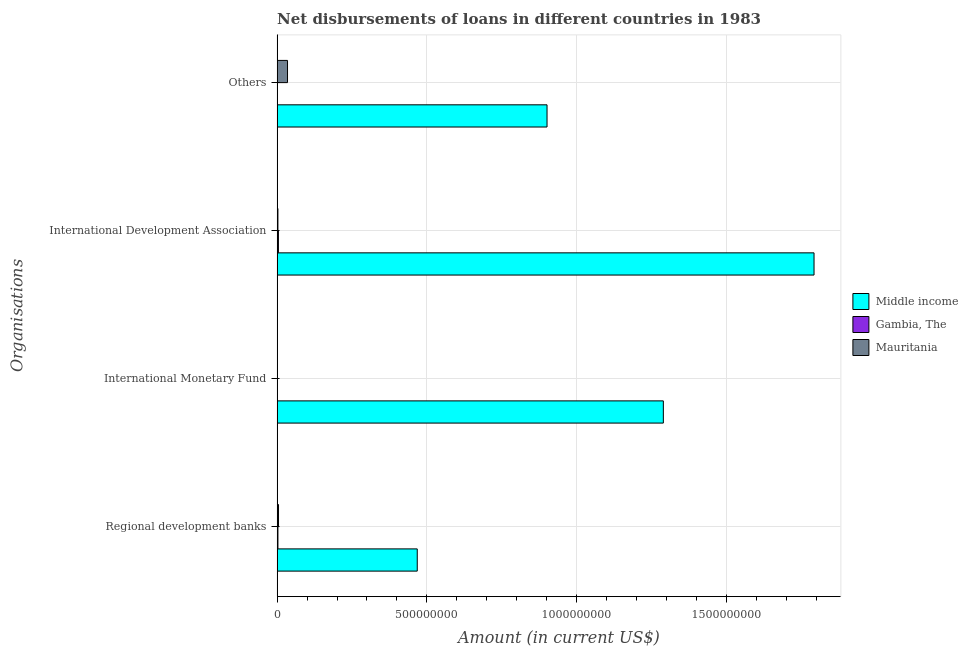Are the number of bars per tick equal to the number of legend labels?
Your answer should be very brief. No. Are the number of bars on each tick of the Y-axis equal?
Offer a very short reply. No. How many bars are there on the 2nd tick from the top?
Keep it short and to the point. 3. What is the label of the 2nd group of bars from the top?
Provide a succinct answer. International Development Association. What is the amount of loan disimbursed by international monetary fund in Mauritania?
Give a very brief answer. 0. Across all countries, what is the maximum amount of loan disimbursed by other organisations?
Your answer should be compact. 9.01e+08. Across all countries, what is the minimum amount of loan disimbursed by regional development banks?
Keep it short and to the point. 2.71e+06. In which country was the amount of loan disimbursed by other organisations maximum?
Keep it short and to the point. Middle income. What is the total amount of loan disimbursed by other organisations in the graph?
Your answer should be compact. 9.36e+08. What is the difference between the amount of loan disimbursed by international development association in Gambia, The and that in Middle income?
Your response must be concise. -1.79e+09. What is the difference between the amount of loan disimbursed by international development association in Middle income and the amount of loan disimbursed by other organisations in Mauritania?
Ensure brevity in your answer.  1.76e+09. What is the average amount of loan disimbursed by international development association per country?
Your response must be concise. 6.00e+08. What is the difference between the amount of loan disimbursed by international development association and amount of loan disimbursed by regional development banks in Mauritania?
Your answer should be very brief. -1.99e+06. What is the ratio of the amount of loan disimbursed by regional development banks in Gambia, The to that in Middle income?
Offer a very short reply. 0.01. What is the difference between the highest and the second highest amount of loan disimbursed by regional development banks?
Provide a succinct answer. 4.63e+08. What is the difference between the highest and the lowest amount of loan disimbursed by regional development banks?
Offer a very short reply. 4.65e+08. In how many countries, is the amount of loan disimbursed by international development association greater than the average amount of loan disimbursed by international development association taken over all countries?
Ensure brevity in your answer.  1. Is the sum of the amount of loan disimbursed by regional development banks in Middle income and Gambia, The greater than the maximum amount of loan disimbursed by other organisations across all countries?
Offer a terse response. No. Is it the case that in every country, the sum of the amount of loan disimbursed by other organisations and amount of loan disimbursed by international development association is greater than the sum of amount of loan disimbursed by regional development banks and amount of loan disimbursed by international monetary fund?
Your answer should be compact. No. Is it the case that in every country, the sum of the amount of loan disimbursed by regional development banks and amount of loan disimbursed by international monetary fund is greater than the amount of loan disimbursed by international development association?
Your answer should be very brief. No. What is the difference between two consecutive major ticks on the X-axis?
Offer a very short reply. 5.00e+08. Are the values on the major ticks of X-axis written in scientific E-notation?
Ensure brevity in your answer.  No. What is the title of the graph?
Offer a very short reply. Net disbursements of loans in different countries in 1983. What is the label or title of the Y-axis?
Your answer should be compact. Organisations. What is the Amount (in current US$) in Middle income in Regional development banks?
Provide a short and direct response. 4.68e+08. What is the Amount (in current US$) of Gambia, The in Regional development banks?
Offer a terse response. 2.71e+06. What is the Amount (in current US$) of Mauritania in Regional development banks?
Your response must be concise. 4.66e+06. What is the Amount (in current US$) of Middle income in International Monetary Fund?
Keep it short and to the point. 1.29e+09. What is the Amount (in current US$) of Middle income in International Development Association?
Your response must be concise. 1.79e+09. What is the Amount (in current US$) in Gambia, The in International Development Association?
Provide a short and direct response. 4.33e+06. What is the Amount (in current US$) of Mauritania in International Development Association?
Ensure brevity in your answer.  2.67e+06. What is the Amount (in current US$) of Middle income in Others?
Offer a very short reply. 9.01e+08. What is the Amount (in current US$) of Mauritania in Others?
Offer a very short reply. 3.47e+07. Across all Organisations, what is the maximum Amount (in current US$) in Middle income?
Provide a short and direct response. 1.79e+09. Across all Organisations, what is the maximum Amount (in current US$) in Gambia, The?
Keep it short and to the point. 4.33e+06. Across all Organisations, what is the maximum Amount (in current US$) of Mauritania?
Provide a short and direct response. 3.47e+07. Across all Organisations, what is the minimum Amount (in current US$) in Middle income?
Provide a short and direct response. 4.68e+08. Across all Organisations, what is the minimum Amount (in current US$) of Gambia, The?
Make the answer very short. 0. What is the total Amount (in current US$) in Middle income in the graph?
Provide a succinct answer. 4.45e+09. What is the total Amount (in current US$) of Gambia, The in the graph?
Provide a succinct answer. 7.04e+06. What is the total Amount (in current US$) of Mauritania in the graph?
Your answer should be very brief. 4.21e+07. What is the difference between the Amount (in current US$) of Middle income in Regional development banks and that in International Monetary Fund?
Your answer should be compact. -8.22e+08. What is the difference between the Amount (in current US$) of Middle income in Regional development banks and that in International Development Association?
Your response must be concise. -1.33e+09. What is the difference between the Amount (in current US$) of Gambia, The in Regional development banks and that in International Development Association?
Provide a short and direct response. -1.62e+06. What is the difference between the Amount (in current US$) in Mauritania in Regional development banks and that in International Development Association?
Make the answer very short. 1.99e+06. What is the difference between the Amount (in current US$) in Middle income in Regional development banks and that in Others?
Provide a short and direct response. -4.33e+08. What is the difference between the Amount (in current US$) in Mauritania in Regional development banks and that in Others?
Your response must be concise. -3.01e+07. What is the difference between the Amount (in current US$) in Middle income in International Monetary Fund and that in International Development Association?
Offer a very short reply. -5.03e+08. What is the difference between the Amount (in current US$) of Middle income in International Monetary Fund and that in Others?
Ensure brevity in your answer.  3.88e+08. What is the difference between the Amount (in current US$) of Middle income in International Development Association and that in Others?
Make the answer very short. 8.92e+08. What is the difference between the Amount (in current US$) in Mauritania in International Development Association and that in Others?
Your answer should be very brief. -3.21e+07. What is the difference between the Amount (in current US$) of Middle income in Regional development banks and the Amount (in current US$) of Gambia, The in International Development Association?
Offer a terse response. 4.64e+08. What is the difference between the Amount (in current US$) in Middle income in Regional development banks and the Amount (in current US$) in Mauritania in International Development Association?
Your answer should be very brief. 4.65e+08. What is the difference between the Amount (in current US$) of Middle income in Regional development banks and the Amount (in current US$) of Mauritania in Others?
Your response must be concise. 4.33e+08. What is the difference between the Amount (in current US$) of Gambia, The in Regional development banks and the Amount (in current US$) of Mauritania in Others?
Your response must be concise. -3.20e+07. What is the difference between the Amount (in current US$) in Middle income in International Monetary Fund and the Amount (in current US$) in Gambia, The in International Development Association?
Your answer should be compact. 1.29e+09. What is the difference between the Amount (in current US$) in Middle income in International Monetary Fund and the Amount (in current US$) in Mauritania in International Development Association?
Your response must be concise. 1.29e+09. What is the difference between the Amount (in current US$) of Middle income in International Monetary Fund and the Amount (in current US$) of Mauritania in Others?
Your answer should be very brief. 1.26e+09. What is the difference between the Amount (in current US$) of Middle income in International Development Association and the Amount (in current US$) of Mauritania in Others?
Your response must be concise. 1.76e+09. What is the difference between the Amount (in current US$) in Gambia, The in International Development Association and the Amount (in current US$) in Mauritania in Others?
Your response must be concise. -3.04e+07. What is the average Amount (in current US$) in Middle income per Organisations?
Offer a very short reply. 1.11e+09. What is the average Amount (in current US$) of Gambia, The per Organisations?
Offer a very short reply. 1.76e+06. What is the average Amount (in current US$) of Mauritania per Organisations?
Your answer should be compact. 1.05e+07. What is the difference between the Amount (in current US$) in Middle income and Amount (in current US$) in Gambia, The in Regional development banks?
Your response must be concise. 4.65e+08. What is the difference between the Amount (in current US$) of Middle income and Amount (in current US$) of Mauritania in Regional development banks?
Ensure brevity in your answer.  4.63e+08. What is the difference between the Amount (in current US$) in Gambia, The and Amount (in current US$) in Mauritania in Regional development banks?
Your answer should be compact. -1.95e+06. What is the difference between the Amount (in current US$) of Middle income and Amount (in current US$) of Gambia, The in International Development Association?
Ensure brevity in your answer.  1.79e+09. What is the difference between the Amount (in current US$) in Middle income and Amount (in current US$) in Mauritania in International Development Association?
Your answer should be very brief. 1.79e+09. What is the difference between the Amount (in current US$) in Gambia, The and Amount (in current US$) in Mauritania in International Development Association?
Provide a succinct answer. 1.66e+06. What is the difference between the Amount (in current US$) of Middle income and Amount (in current US$) of Mauritania in Others?
Provide a short and direct response. 8.67e+08. What is the ratio of the Amount (in current US$) of Middle income in Regional development banks to that in International Monetary Fund?
Make the answer very short. 0.36. What is the ratio of the Amount (in current US$) of Middle income in Regional development banks to that in International Development Association?
Your answer should be very brief. 0.26. What is the ratio of the Amount (in current US$) in Gambia, The in Regional development banks to that in International Development Association?
Make the answer very short. 0.63. What is the ratio of the Amount (in current US$) in Mauritania in Regional development banks to that in International Development Association?
Provide a succinct answer. 1.74. What is the ratio of the Amount (in current US$) in Middle income in Regional development banks to that in Others?
Make the answer very short. 0.52. What is the ratio of the Amount (in current US$) of Mauritania in Regional development banks to that in Others?
Your response must be concise. 0.13. What is the ratio of the Amount (in current US$) in Middle income in International Monetary Fund to that in International Development Association?
Ensure brevity in your answer.  0.72. What is the ratio of the Amount (in current US$) in Middle income in International Monetary Fund to that in Others?
Provide a succinct answer. 1.43. What is the ratio of the Amount (in current US$) in Middle income in International Development Association to that in Others?
Keep it short and to the point. 1.99. What is the ratio of the Amount (in current US$) in Mauritania in International Development Association to that in Others?
Keep it short and to the point. 0.08. What is the difference between the highest and the second highest Amount (in current US$) in Middle income?
Provide a succinct answer. 5.03e+08. What is the difference between the highest and the second highest Amount (in current US$) in Mauritania?
Your answer should be very brief. 3.01e+07. What is the difference between the highest and the lowest Amount (in current US$) of Middle income?
Ensure brevity in your answer.  1.33e+09. What is the difference between the highest and the lowest Amount (in current US$) in Gambia, The?
Your answer should be compact. 4.33e+06. What is the difference between the highest and the lowest Amount (in current US$) in Mauritania?
Offer a terse response. 3.47e+07. 